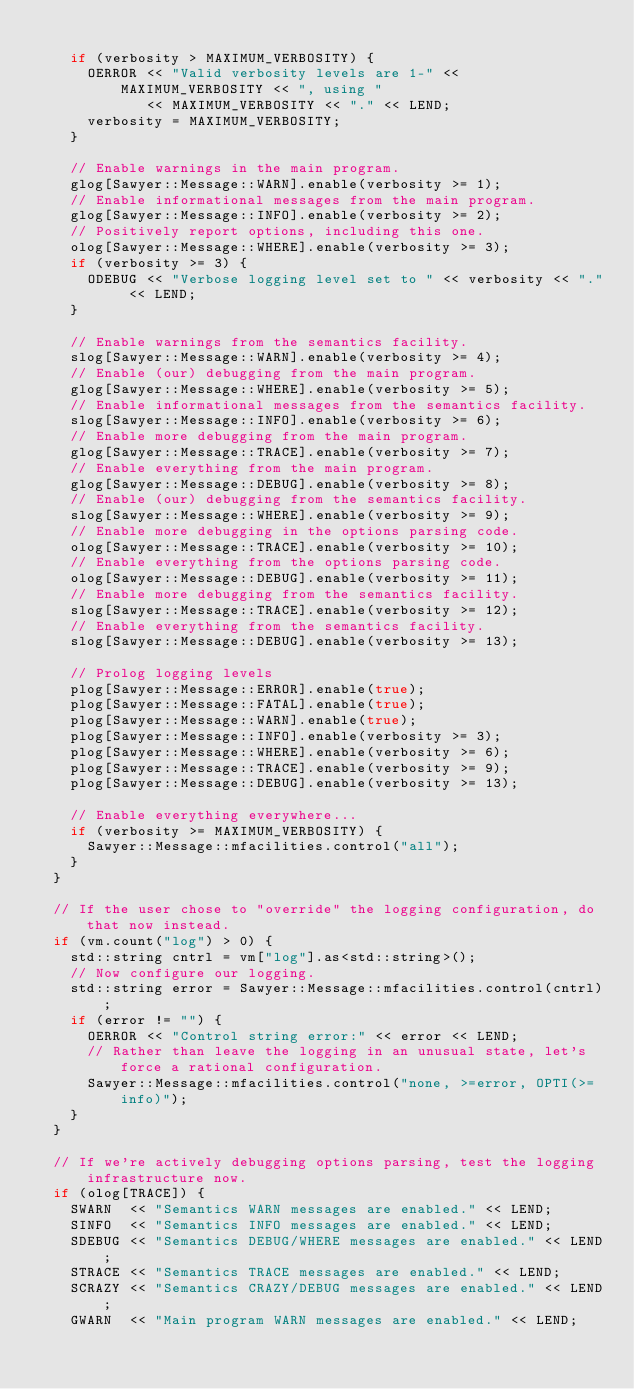<code> <loc_0><loc_0><loc_500><loc_500><_C++_>
    if (verbosity > MAXIMUM_VERBOSITY) {
      OERROR << "Valid verbosity levels are 1-" << MAXIMUM_VERBOSITY << ", using "
             << MAXIMUM_VERBOSITY << "." << LEND;
      verbosity = MAXIMUM_VERBOSITY;
    }

    // Enable warnings in the main program.
    glog[Sawyer::Message::WARN].enable(verbosity >= 1);
    // Enable informational messages from the main program.
    glog[Sawyer::Message::INFO].enable(verbosity >= 2);
    // Positively report options, including this one.
    olog[Sawyer::Message::WHERE].enable(verbosity >= 3);
    if (verbosity >= 3) {
      ODEBUG << "Verbose logging level set to " << verbosity << "." << LEND;
    }

    // Enable warnings from the semantics facility.
    slog[Sawyer::Message::WARN].enable(verbosity >= 4);
    // Enable (our) debugging from the main program.
    glog[Sawyer::Message::WHERE].enable(verbosity >= 5);
    // Enable informational messages from the semantics facility.
    slog[Sawyer::Message::INFO].enable(verbosity >= 6);
    // Enable more debugging from the main program.
    glog[Sawyer::Message::TRACE].enable(verbosity >= 7);
    // Enable everything from the main program.
    glog[Sawyer::Message::DEBUG].enable(verbosity >= 8);
    // Enable (our) debugging from the semantics facility.
    slog[Sawyer::Message::WHERE].enable(verbosity >= 9);
    // Enable more debugging in the options parsing code.
    olog[Sawyer::Message::TRACE].enable(verbosity >= 10);
    // Enable everything from the options parsing code.
    olog[Sawyer::Message::DEBUG].enable(verbosity >= 11);
    // Enable more debugging from the semantics facility.
    slog[Sawyer::Message::TRACE].enable(verbosity >= 12);
    // Enable everything from the semantics facility.
    slog[Sawyer::Message::DEBUG].enable(verbosity >= 13);

    // Prolog logging levels
    plog[Sawyer::Message::ERROR].enable(true);
    plog[Sawyer::Message::FATAL].enable(true);
    plog[Sawyer::Message::WARN].enable(true);
    plog[Sawyer::Message::INFO].enable(verbosity >= 3);
    plog[Sawyer::Message::WHERE].enable(verbosity >= 6);
    plog[Sawyer::Message::TRACE].enable(verbosity >= 9);
    plog[Sawyer::Message::DEBUG].enable(verbosity >= 13);

    // Enable everything everywhere...
    if (verbosity >= MAXIMUM_VERBOSITY) {
      Sawyer::Message::mfacilities.control("all");
    }
  }

  // If the user chose to "override" the logging configuration, do that now instead.
  if (vm.count("log") > 0) {
    std::string cntrl = vm["log"].as<std::string>();
    // Now configure our logging.
    std::string error = Sawyer::Message::mfacilities.control(cntrl);
    if (error != "") {
      OERROR << "Control string error:" << error << LEND;
      // Rather than leave the logging in an unusual state, let's force a rational configuration.
      Sawyer::Message::mfacilities.control("none, >=error, OPTI(>=info)");
    }
  }

  // If we're actively debugging options parsing, test the logging infrastructure now.
  if (olog[TRACE]) {
    SWARN  << "Semantics WARN messages are enabled." << LEND;
    SINFO  << "Semantics INFO messages are enabled." << LEND;
    SDEBUG << "Semantics DEBUG/WHERE messages are enabled." << LEND;
    STRACE << "Semantics TRACE messages are enabled." << LEND;
    SCRAZY << "Semantics CRAZY/DEBUG messages are enabled." << LEND;
    GWARN  << "Main program WARN messages are enabled." << LEND;</code> 